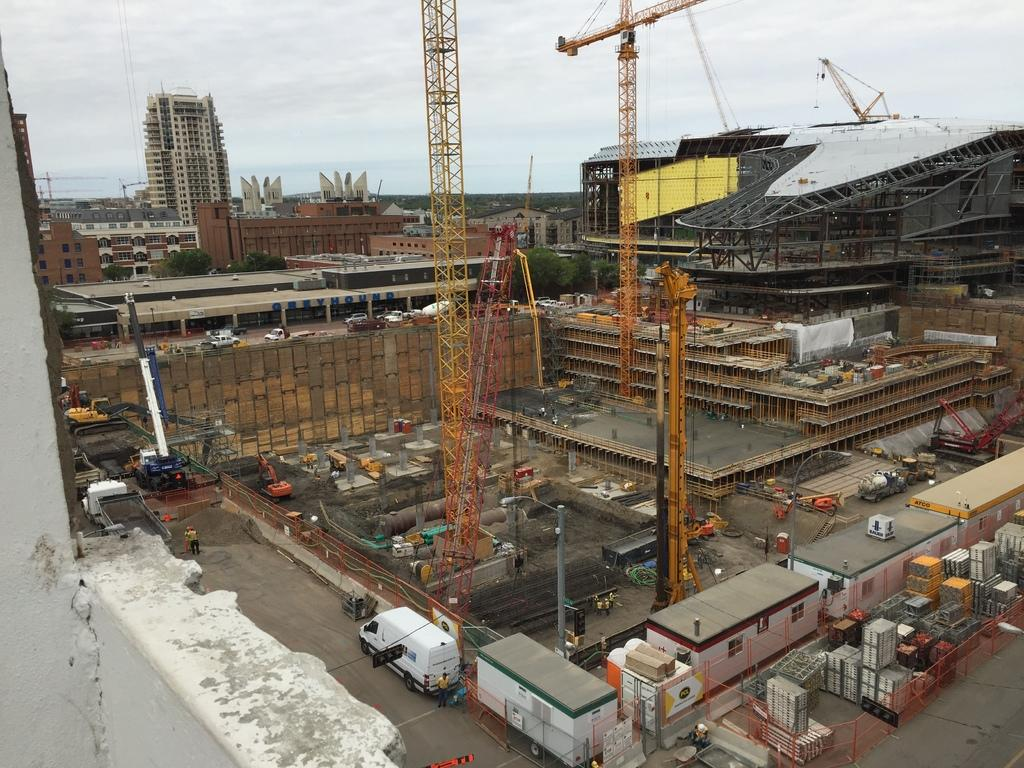What type of location is shown in the image? The image depicts a construction site. What large machines can be seen at the construction site? There are cranes present at the construction site. What type of temporary structures are present at the site? There are cabins present at the site. What types of vehicles can be seen at the construction site? Vehicles are visible in the image. What can be seen in the distance behind the construction site? There are buildings in the background. What is visible at the top of the image? The sky is visible at the top of the image. How many girls are sleeping in the cabins in the image? There are no girls or sleeping quarters present in the image; it depicts a construction site with cabins used for other purposes. 